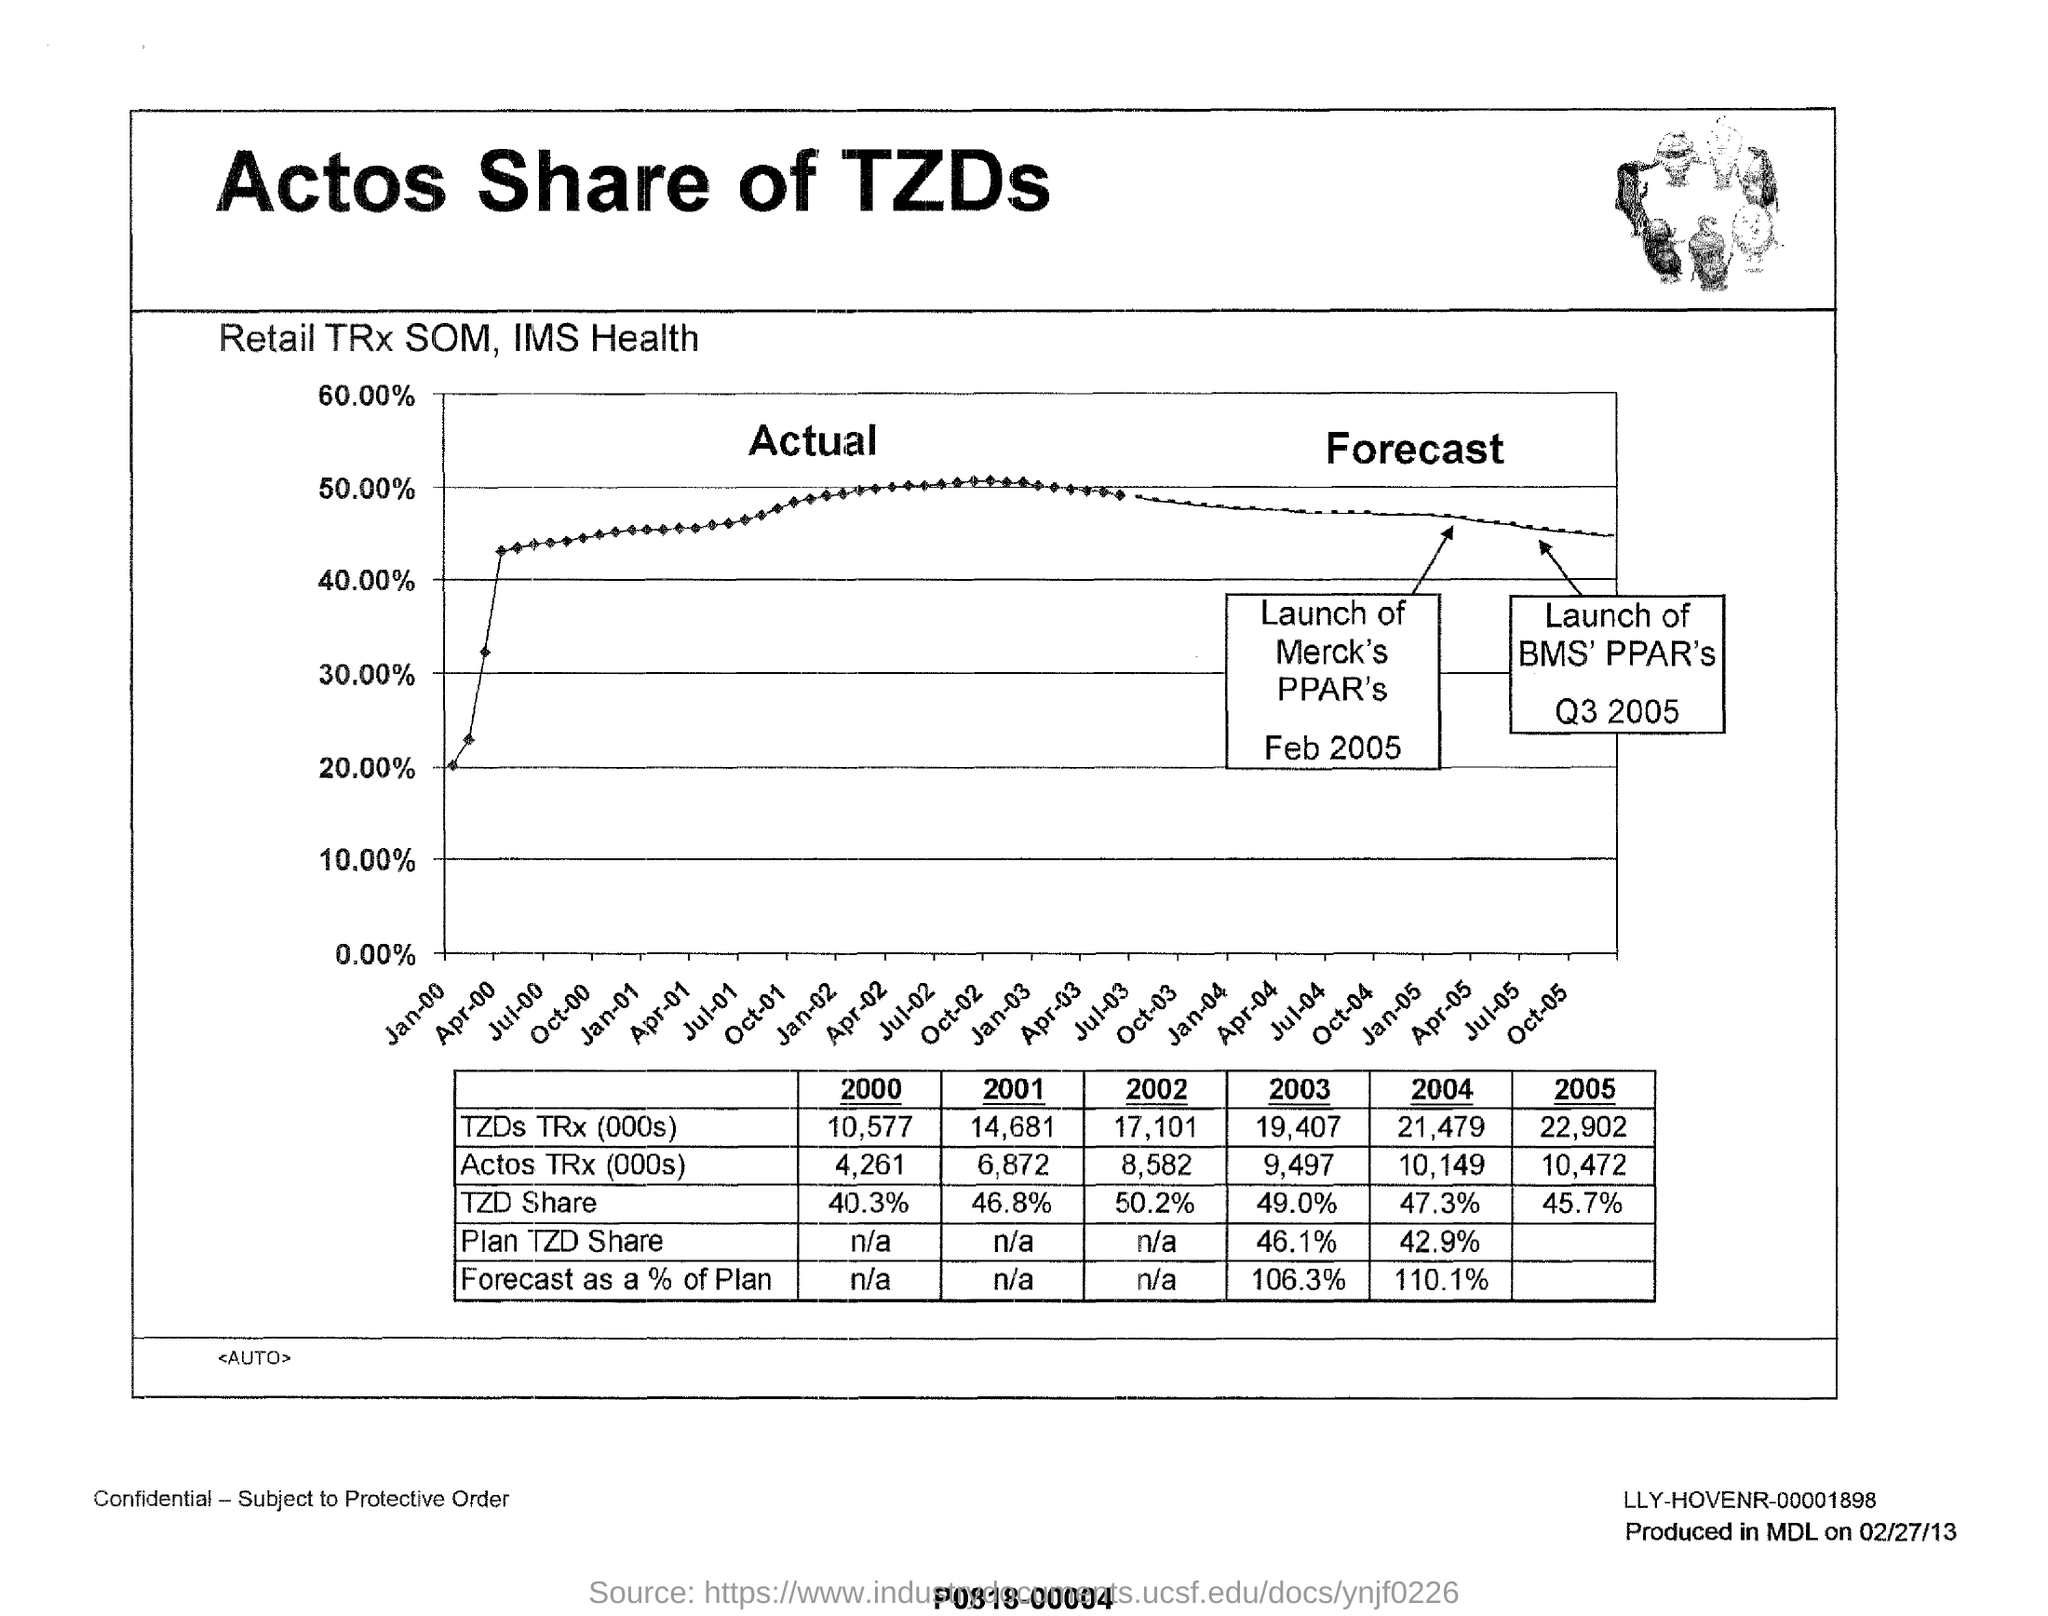Draw attention to some important aspects in this diagram. The TZD's TRx (transactions) in the year 2005 was 22,902. In the year 2000, TZD's share was 40.3%. The percentage of plan TZD shares in the year 2004 was 42.9%. Merck launched PPARs in February 2005. In the year 2003, there were 9,497 cases of Actos TRx. 